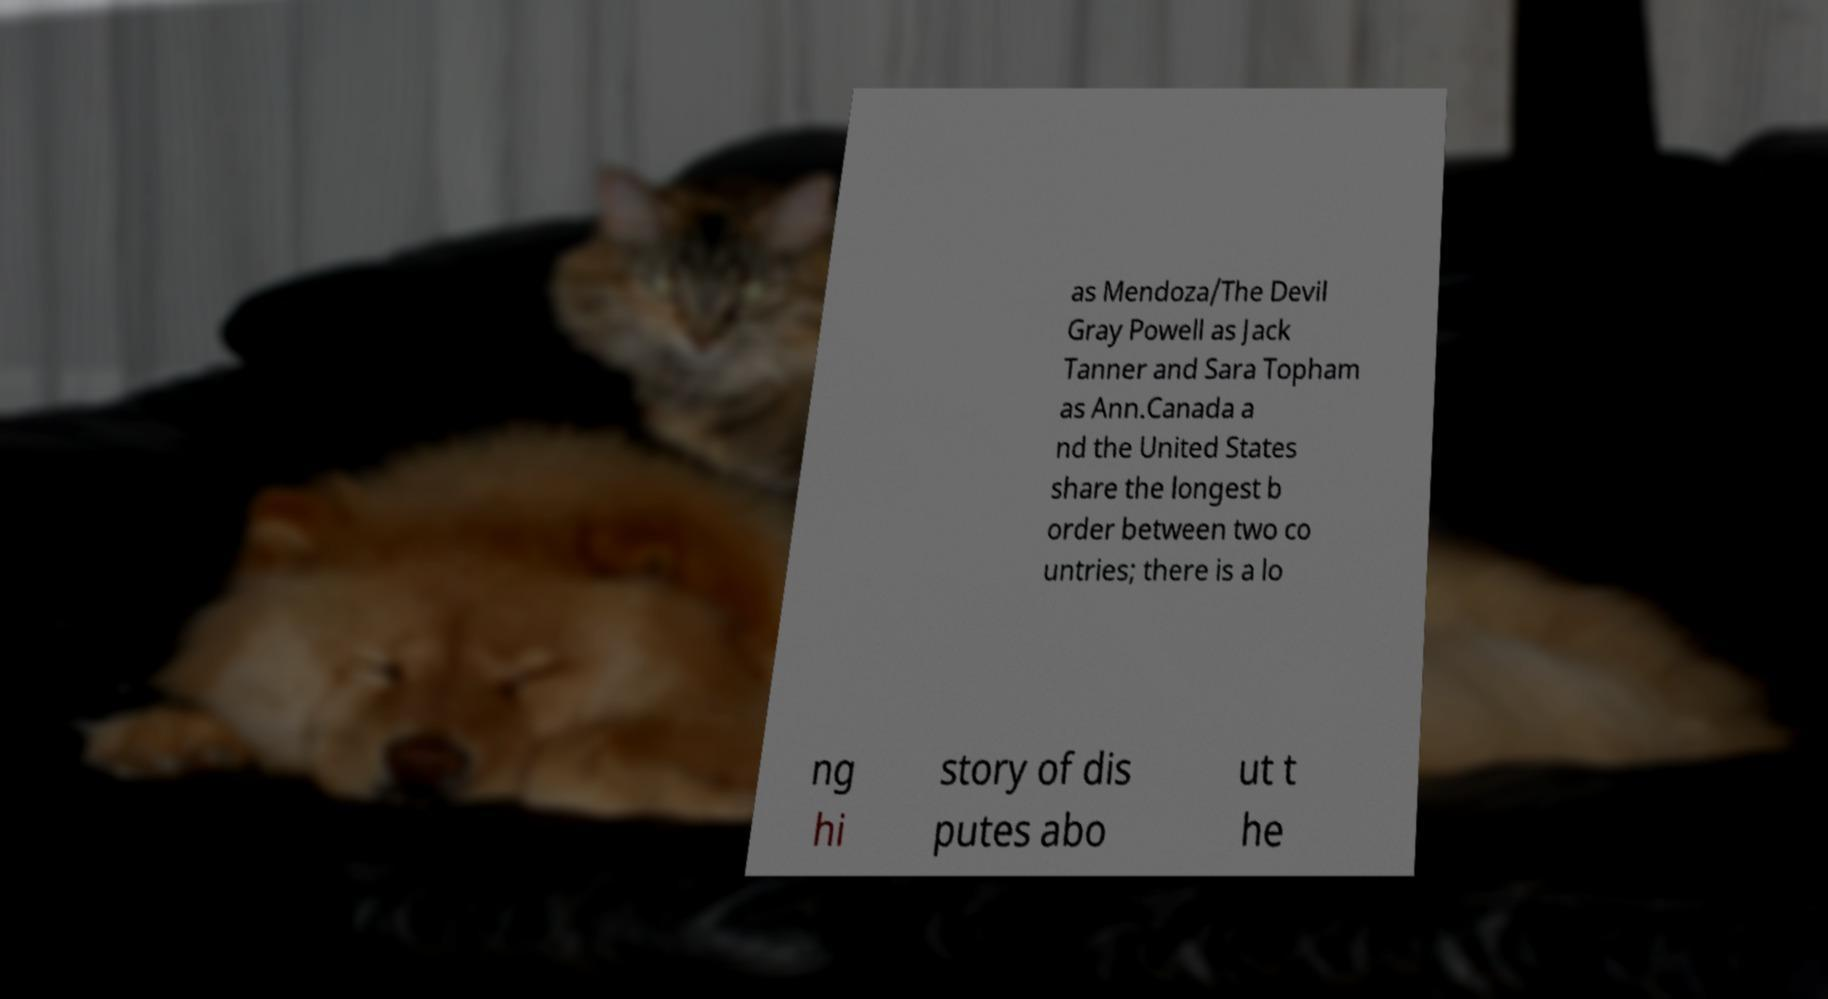Can you read and provide the text displayed in the image?This photo seems to have some interesting text. Can you extract and type it out for me? as Mendoza/The Devil Gray Powell as Jack Tanner and Sara Topham as Ann.Canada a nd the United States share the longest b order between two co untries; there is a lo ng hi story of dis putes abo ut t he 